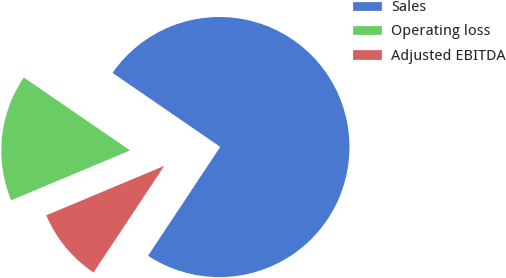Convert chart. <chart><loc_0><loc_0><loc_500><loc_500><pie_chart><fcel>Sales<fcel>Operating loss<fcel>Adjusted EBITDA<nl><fcel>74.75%<fcel>15.9%<fcel>9.36%<nl></chart> 